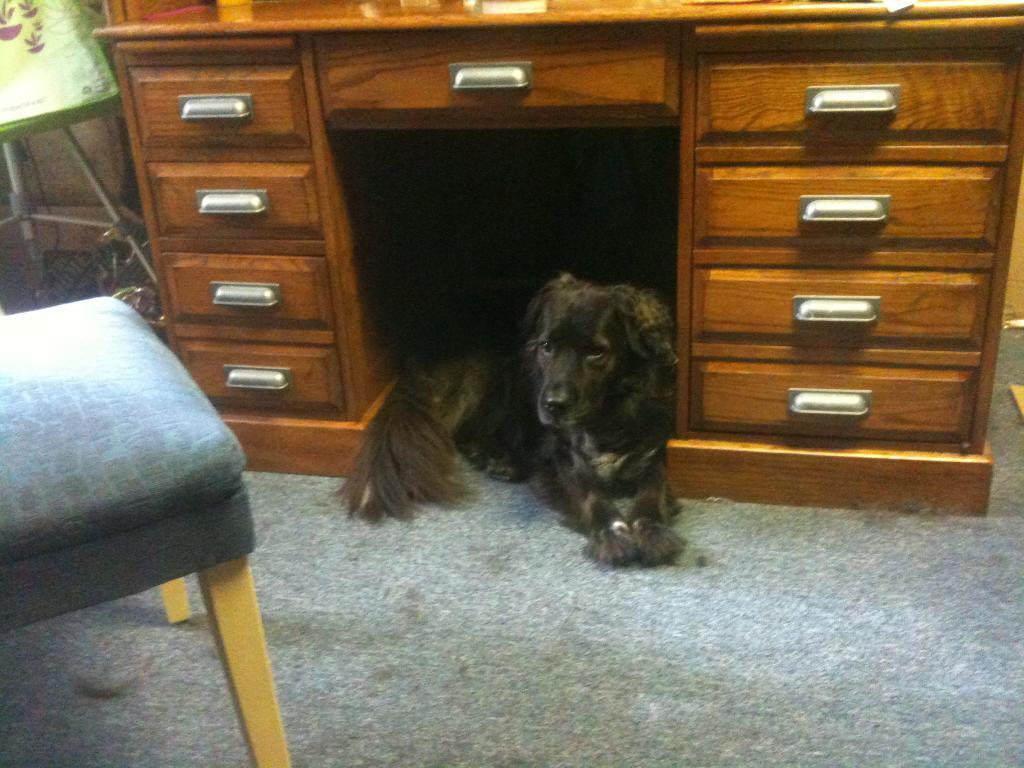How would you summarize this image in a sentence or two? In the picture there is a cupboard. Inside the cupboard there is a dog sitting which is in black color. There is a floor mat on the floor. To the left side there is a chair which is in blue color. On the top left corner there is a lamp. 